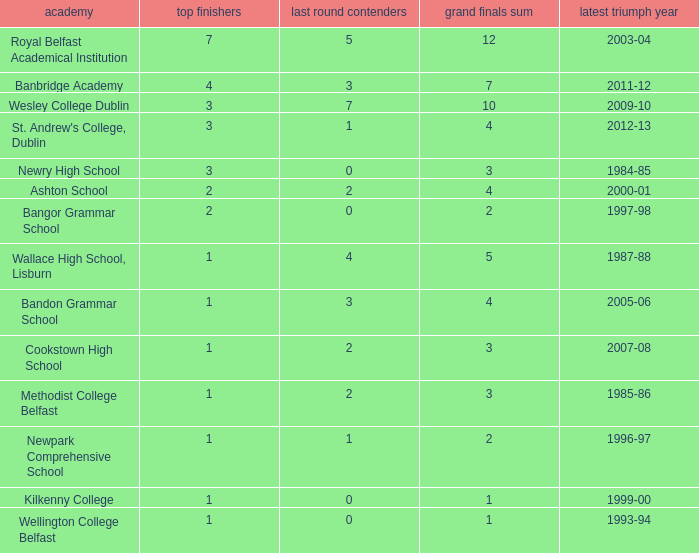How many total finals where there when the last win was in 2012-13? 4.0. Parse the table in full. {'header': ['academy', 'top finishers', 'last round contenders', 'grand finals sum', 'latest triumph year'], 'rows': [['Royal Belfast Academical Institution', '7', '5', '12', '2003-04'], ['Banbridge Academy', '4', '3', '7', '2011-12'], ['Wesley College Dublin', '3', '7', '10', '2009-10'], ["St. Andrew's College, Dublin", '3', '1', '4', '2012-13'], ['Newry High School', '3', '0', '3', '1984-85'], ['Ashton School', '2', '2', '4', '2000-01'], ['Bangor Grammar School', '2', '0', '2', '1997-98'], ['Wallace High School, Lisburn', '1', '4', '5', '1987-88'], ['Bandon Grammar School', '1', '3', '4', '2005-06'], ['Cookstown High School', '1', '2', '3', '2007-08'], ['Methodist College Belfast', '1', '2', '3', '1985-86'], ['Newpark Comprehensive School', '1', '1', '2', '1996-97'], ['Kilkenny College', '1', '0', '1', '1999-00'], ['Wellington College Belfast', '1', '0', '1', '1993-94']]} 